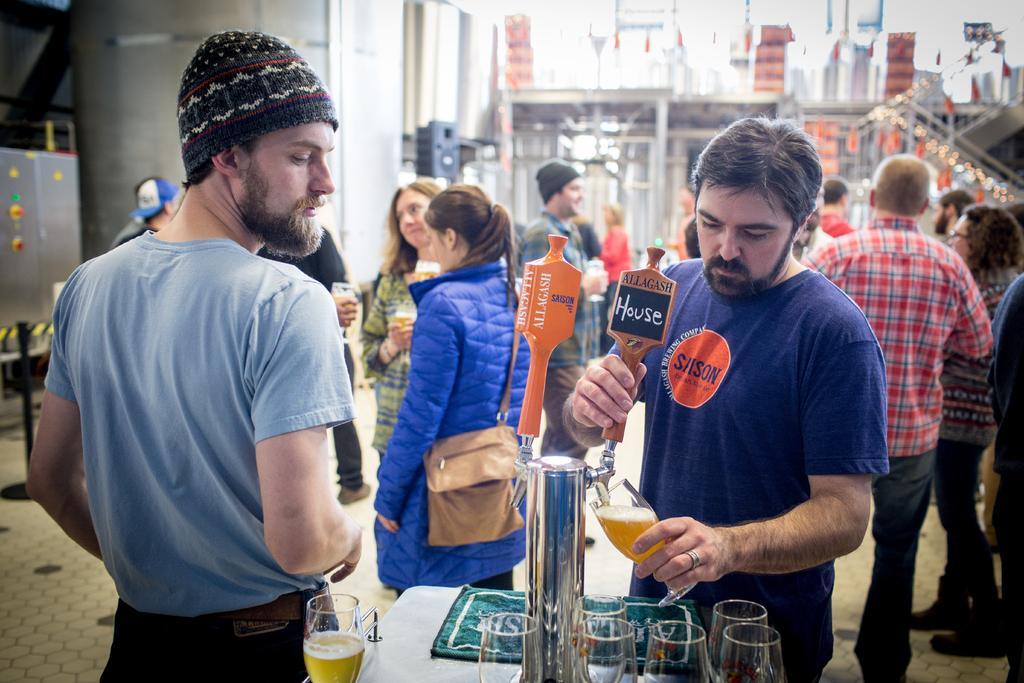How would you summarize this image in a sentence or two? In this picture,there are group of people. A man in blue T shirt is filling wine glass. The man beside him with a cap is watching the process. And behind them there is a girl with a blue winter coat with a backpack hanging to her back. The location as if they are in outside area. The people are in a joyful mood. 